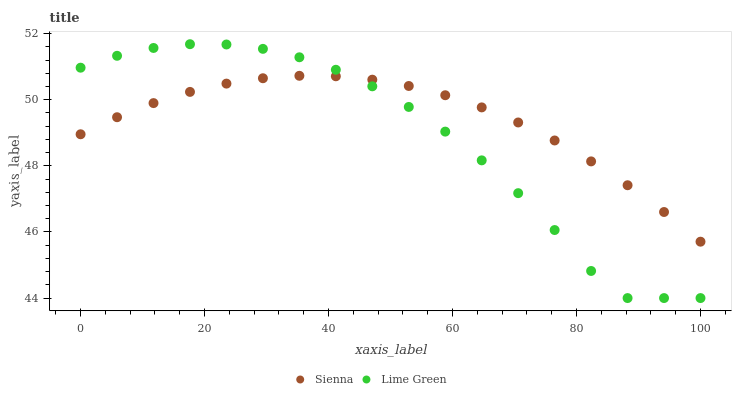Does Lime Green have the minimum area under the curve?
Answer yes or no. Yes. Does Sienna have the maximum area under the curve?
Answer yes or no. Yes. Does Lime Green have the maximum area under the curve?
Answer yes or no. No. Is Sienna the smoothest?
Answer yes or no. Yes. Is Lime Green the roughest?
Answer yes or no. Yes. Is Lime Green the smoothest?
Answer yes or no. No. Does Lime Green have the lowest value?
Answer yes or no. Yes. Does Lime Green have the highest value?
Answer yes or no. Yes. Does Sienna intersect Lime Green?
Answer yes or no. Yes. Is Sienna less than Lime Green?
Answer yes or no. No. Is Sienna greater than Lime Green?
Answer yes or no. No. 